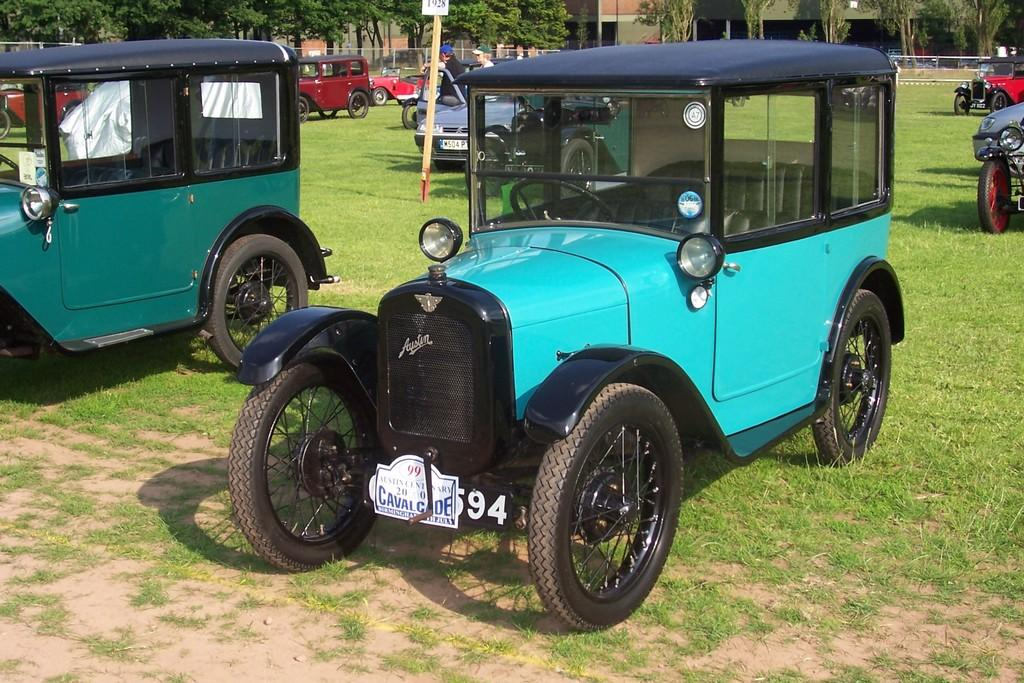What is on the grass in the image? There are cars on the grass in the image. What can be seen in the distance in the image? There are trees and buildings in the background of the image. What is separating the grassy area from the background in the image? There is a fence visible in the image. What is the father teaching his children in the image? There is no father or children present in the image; it only features cars on the grass, trees and buildings in the background, and a fence. 